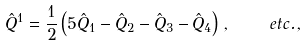<formula> <loc_0><loc_0><loc_500><loc_500>\hat { Q } ^ { 1 } = \frac { 1 } { 2 } \left ( 5 \hat { Q } _ { 1 } - \hat { Q } _ { 2 } - \hat { Q } _ { 3 } - \hat { Q } _ { 4 } \right ) \, , \quad e t c . \, ,</formula> 